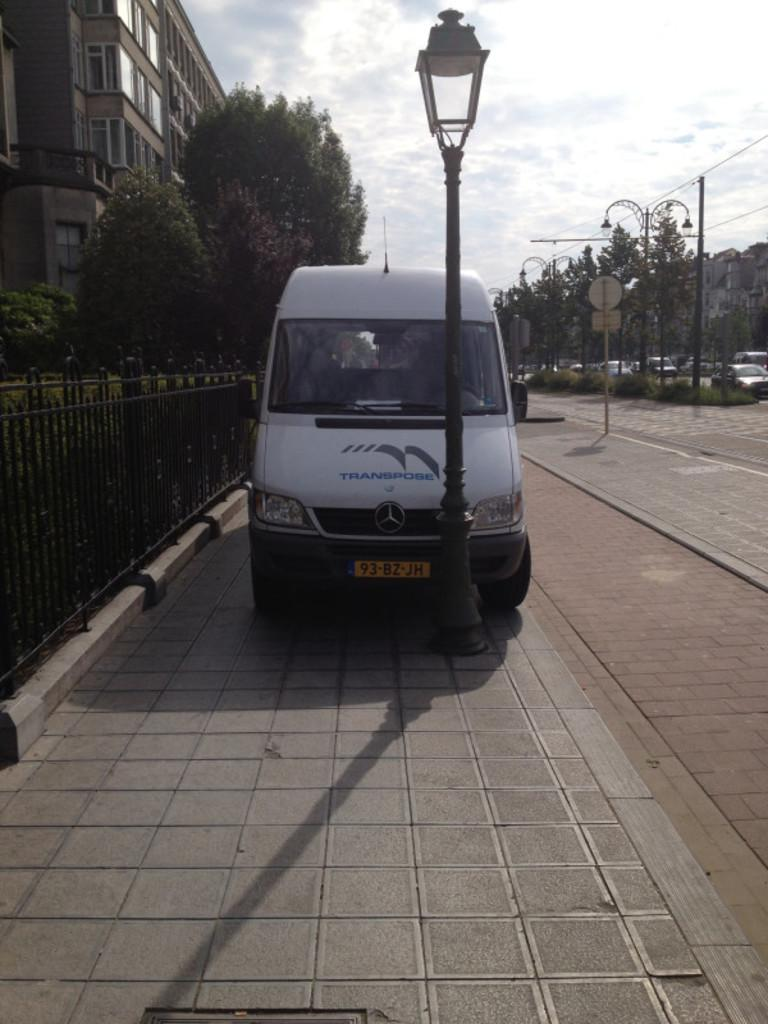<image>
Share a concise interpretation of the image provided. A van with the license plate 93-BZ-JH is parked on a sidewalk by a lamp post. 